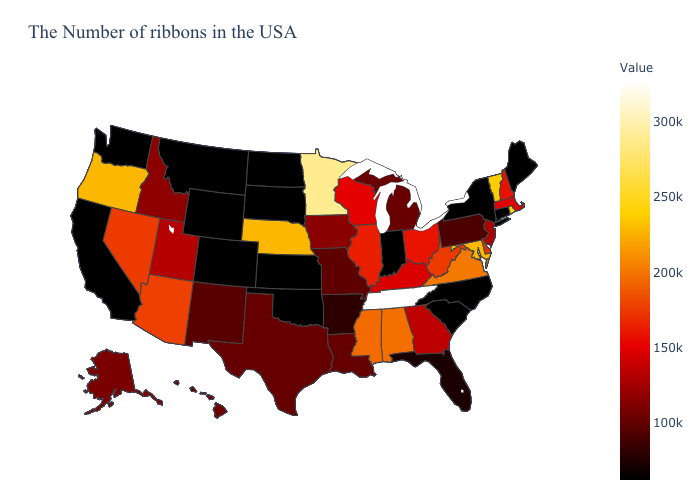Which states hav the highest value in the Northeast?
Write a very short answer. Rhode Island. Among the states that border Nebraska , which have the highest value?
Be succinct. Iowa. Does Maryland have a lower value than Montana?
Write a very short answer. No. Does Minnesota have the highest value in the MidWest?
Write a very short answer. Yes. Does Missouri have the highest value in the MidWest?
Concise answer only. No. Among the states that border Arizona , does Nevada have the highest value?
Concise answer only. Yes. Among the states that border Kentucky , does Tennessee have the highest value?
Give a very brief answer. Yes. Among the states that border Maryland , does Virginia have the lowest value?
Answer briefly. No. Which states have the lowest value in the Northeast?
Quick response, please. Maine, Connecticut, New York. Does Montana have the lowest value in the West?
Answer briefly. Yes. 